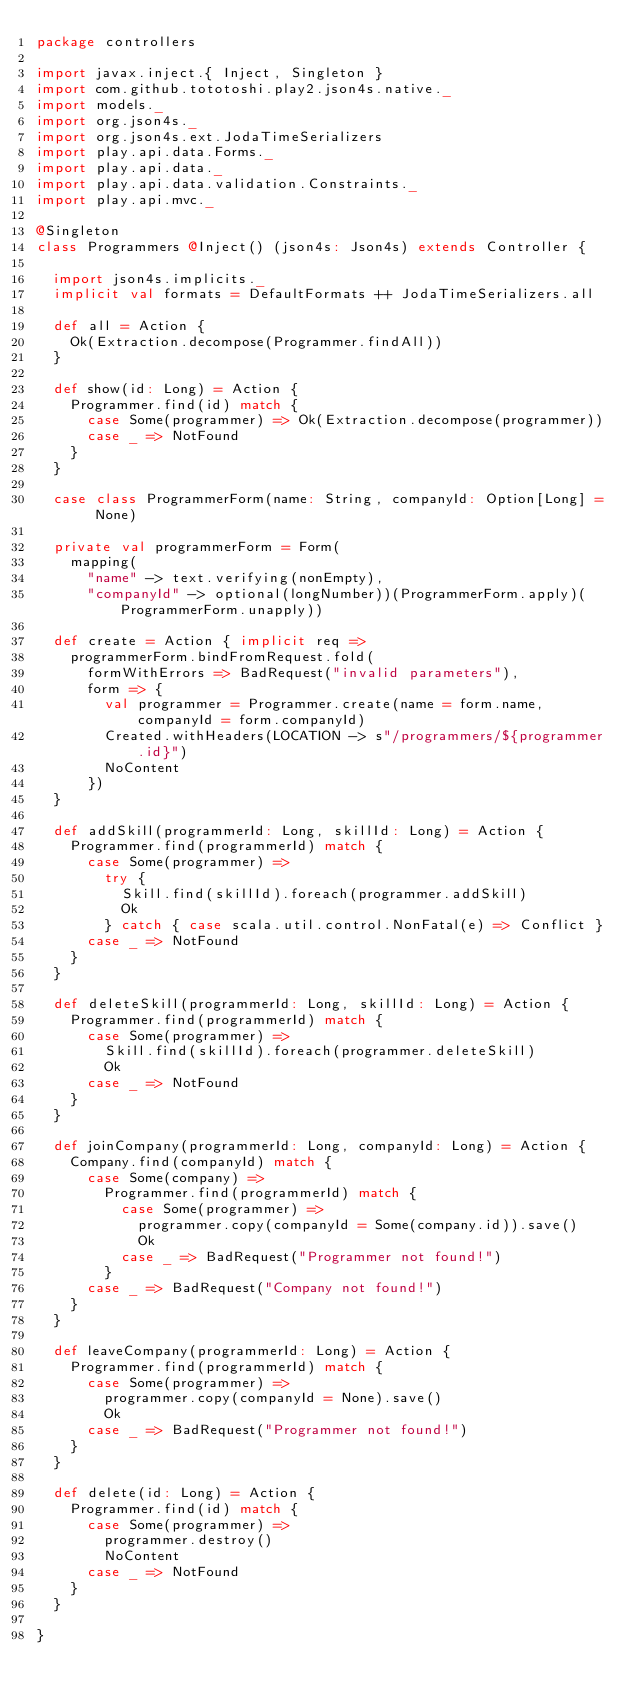<code> <loc_0><loc_0><loc_500><loc_500><_Scala_>package controllers

import javax.inject.{ Inject, Singleton }
import com.github.tototoshi.play2.json4s.native._
import models._
import org.json4s._
import org.json4s.ext.JodaTimeSerializers
import play.api.data.Forms._
import play.api.data._
import play.api.data.validation.Constraints._
import play.api.mvc._

@Singleton
class Programmers @Inject() (json4s: Json4s) extends Controller {

  import json4s.implicits._
  implicit val formats = DefaultFormats ++ JodaTimeSerializers.all

  def all = Action {
    Ok(Extraction.decompose(Programmer.findAll))
  }

  def show(id: Long) = Action {
    Programmer.find(id) match {
      case Some(programmer) => Ok(Extraction.decompose(programmer))
      case _ => NotFound
    }
  }

  case class ProgrammerForm(name: String, companyId: Option[Long] = None)

  private val programmerForm = Form(
    mapping(
      "name" -> text.verifying(nonEmpty),
      "companyId" -> optional(longNumber))(ProgrammerForm.apply)(ProgrammerForm.unapply))

  def create = Action { implicit req =>
    programmerForm.bindFromRequest.fold(
      formWithErrors => BadRequest("invalid parameters"),
      form => {
        val programmer = Programmer.create(name = form.name, companyId = form.companyId)
        Created.withHeaders(LOCATION -> s"/programmers/${programmer.id}")
        NoContent
      })
  }

  def addSkill(programmerId: Long, skillId: Long) = Action {
    Programmer.find(programmerId) match {
      case Some(programmer) =>
        try {
          Skill.find(skillId).foreach(programmer.addSkill)
          Ok
        } catch { case scala.util.control.NonFatal(e) => Conflict }
      case _ => NotFound
    }
  }

  def deleteSkill(programmerId: Long, skillId: Long) = Action {
    Programmer.find(programmerId) match {
      case Some(programmer) =>
        Skill.find(skillId).foreach(programmer.deleteSkill)
        Ok
      case _ => NotFound
    }
  }

  def joinCompany(programmerId: Long, companyId: Long) = Action {
    Company.find(companyId) match {
      case Some(company) =>
        Programmer.find(programmerId) match {
          case Some(programmer) =>
            programmer.copy(companyId = Some(company.id)).save()
            Ok
          case _ => BadRequest("Programmer not found!")
        }
      case _ => BadRequest("Company not found!")
    }
  }

  def leaveCompany(programmerId: Long) = Action {
    Programmer.find(programmerId) match {
      case Some(programmer) =>
        programmer.copy(companyId = None).save()
        Ok
      case _ => BadRequest("Programmer not found!")
    }
  }

  def delete(id: Long) = Action {
    Programmer.find(id) match {
      case Some(programmer) =>
        programmer.destroy()
        NoContent
      case _ => NotFound
    }
  }

}
</code> 